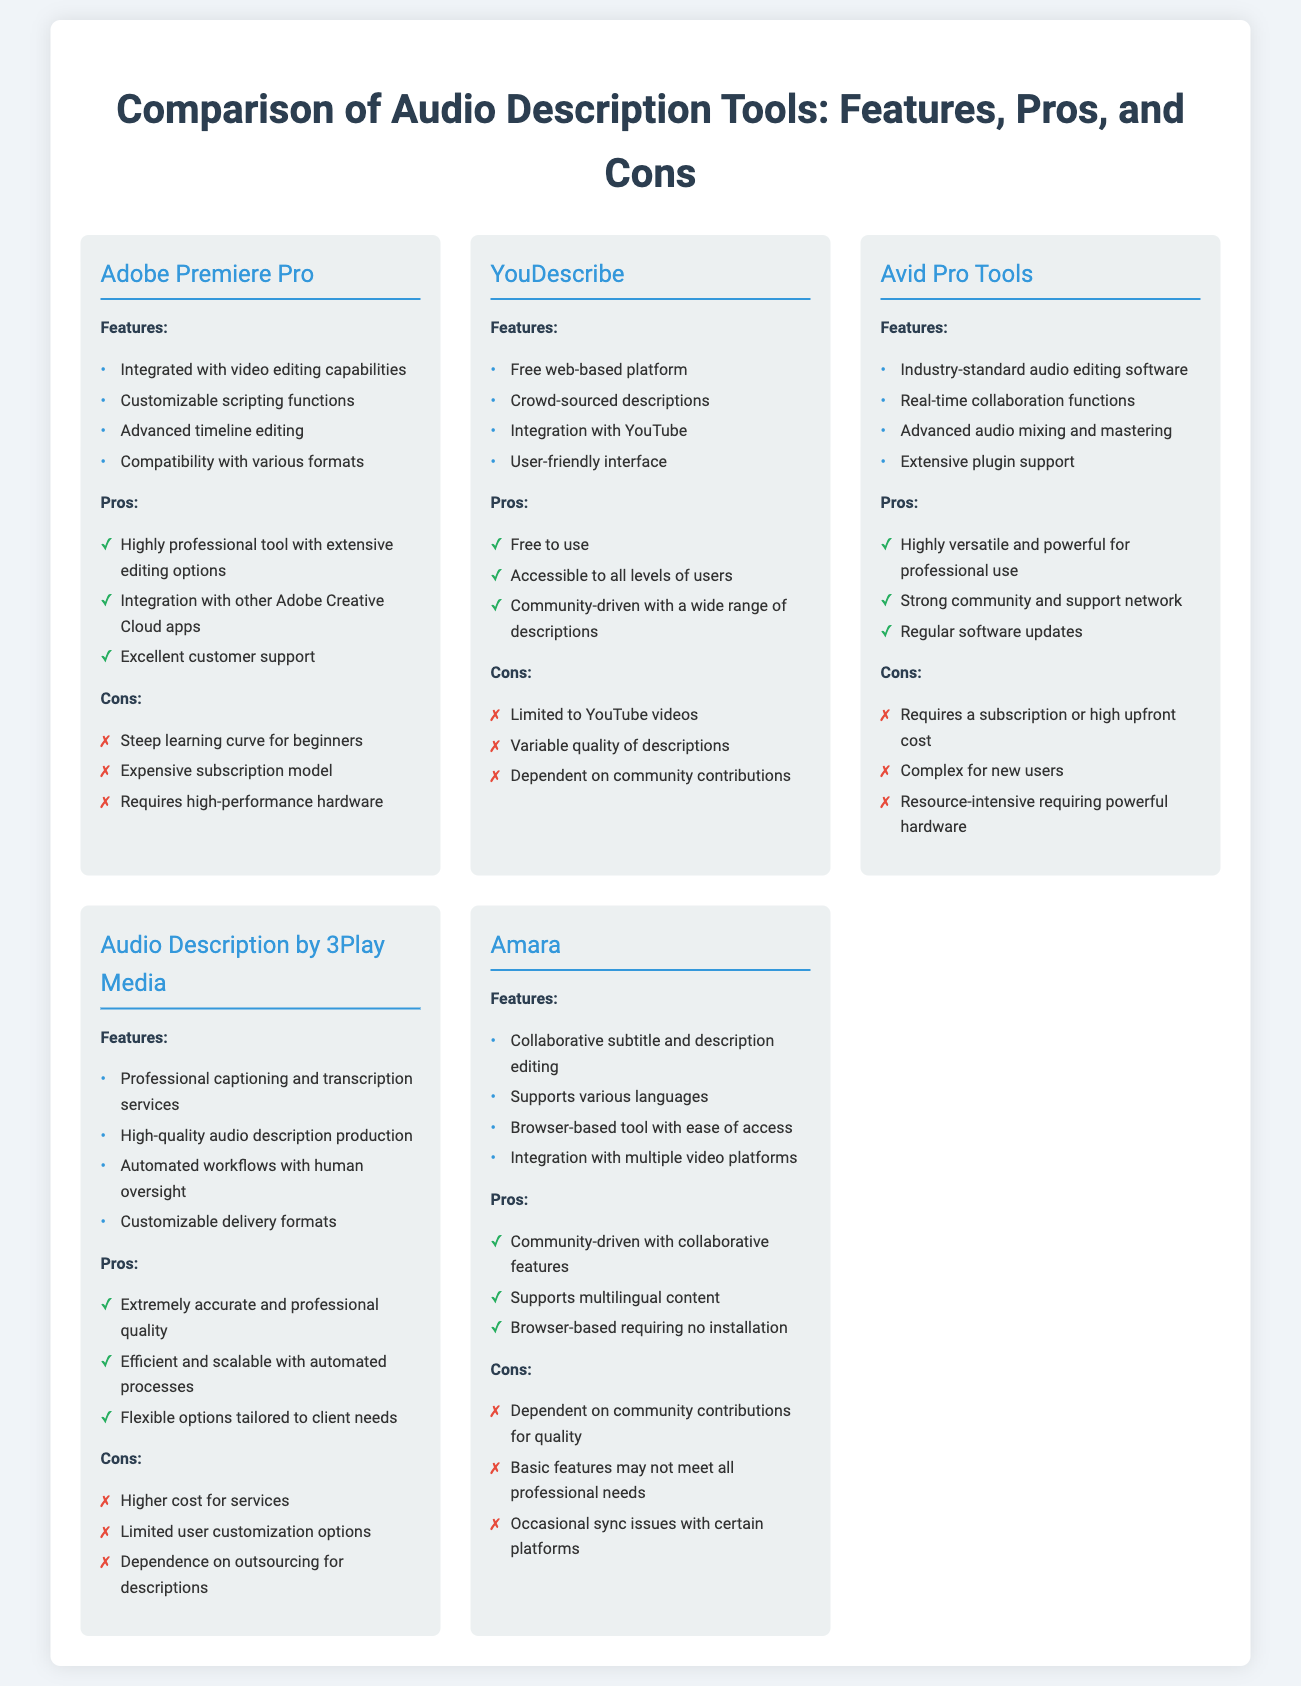What are the features of YouDescribe? The features of YouDescribe include a free web-based platform, crowd-sourced descriptions, integration with YouTube, and a user-friendly interface.
Answer: Free web-based platform, crowd-sourced descriptions, integration with YouTube, user-friendly interface What are the pros of Adobe Premiere Pro? The pros of Adobe Premiere Pro include being a highly professional tool with extensive editing options, integration with other Adobe Creative Cloud apps, and excellent customer support.
Answer: Highly professional tool, integration with other Adobe Creative Cloud apps, excellent customer support What is a major con of Avid Pro Tools? A major con of Avid Pro Tools is that it requires a subscription or high upfront cost.
Answer: Requires a subscription or high upfront cost Which tool is noted for its community-driven descriptions? The tool noted for its community-driven descriptions is YouDescribe.
Answer: YouDescribe How many tools are compared in the document? The document compares a total of five audio description tools.
Answer: Five What feature is common to both YouDescribe and Amara? Both YouDescribe and Amara offer collaborative editing features.
Answer: Collaborative editing features Which audio description tool has real-time collaboration functions? The audio description tool with real-time collaboration functions is Avid Pro Tools.
Answer: Avid Pro Tools What is the main focus of the tool Audio Description by 3Play Media? The main focus of Audio Description by 3Play Media is professional captioning and transcription services.
Answer: Professional captioning and transcription services What is a significant drawback of Amara? A significant drawback of Amara is its dependence on community contributions for quality.
Answer: Dependence on community contributions for quality 